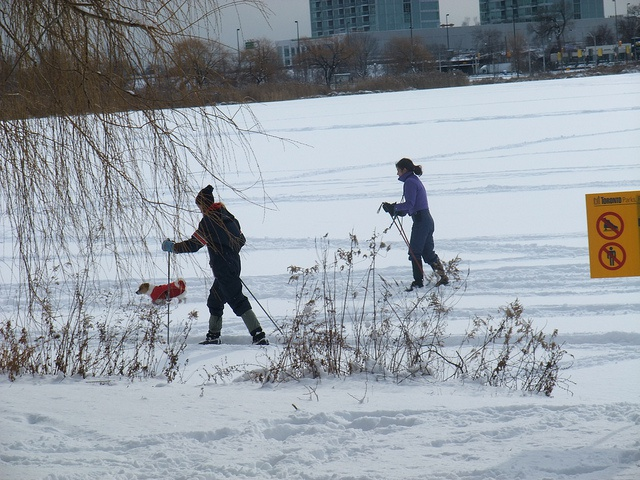Describe the objects in this image and their specific colors. I can see people in gray, black, maroon, and blue tones, people in gray, navy, black, and lightgray tones, dog in gray, maroon, darkgray, and black tones, skis in gray, black, and darkgray tones, and skis in gray, black, darkgray, and darkblue tones in this image. 